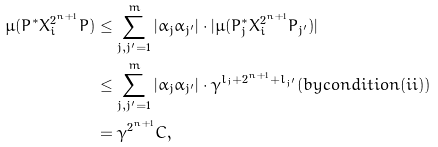Convert formula to latex. <formula><loc_0><loc_0><loc_500><loc_500>\mu ( P ^ { * } X _ { i } ^ { 2 ^ { n + 1 } } P ) & \leq \sum _ { j , j ^ { \prime } = 1 } ^ { m } | \alpha _ { j } \alpha _ { j ^ { \prime } } | \cdot | \mu ( P _ { j } ^ { * } X _ { i } ^ { 2 ^ { n + 1 } } P _ { j ^ { \prime } } ) | \\ & \leq \sum _ { j , j ^ { \prime } = 1 } ^ { m } | \alpha _ { j } \alpha _ { j ^ { \prime } } | \cdot \gamma ^ { l _ { j } + 2 ^ { n + 1 } + l _ { j ^ { \prime } } } ( b y c o n d i t i o n ( i i ) ) \\ & = \gamma ^ { 2 ^ { n + 1 } } C ,</formula> 